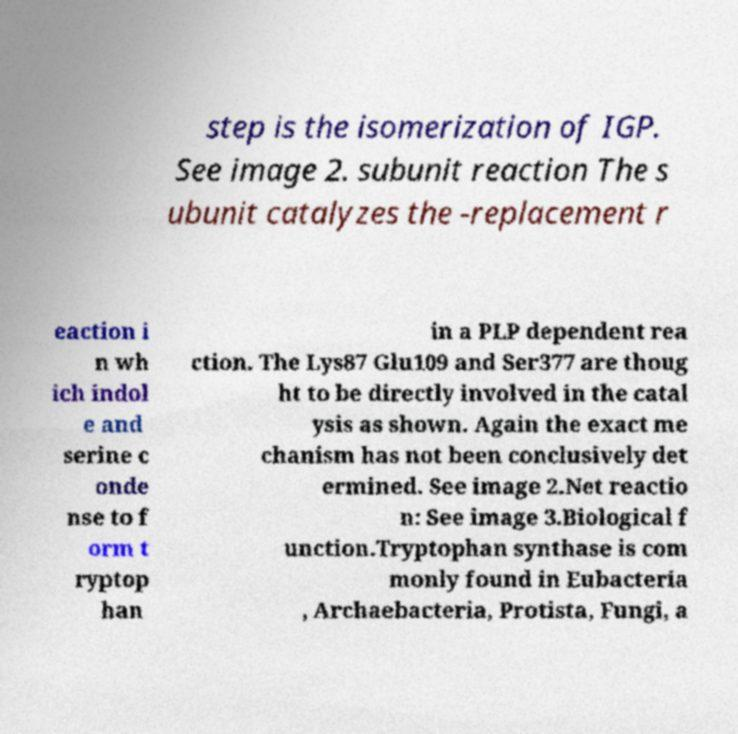Could you extract and type out the text from this image? step is the isomerization of IGP. See image 2. subunit reaction The s ubunit catalyzes the -replacement r eaction i n wh ich indol e and serine c onde nse to f orm t ryptop han in a PLP dependent rea ction. The Lys87 Glu109 and Ser377 are thoug ht to be directly involved in the catal ysis as shown. Again the exact me chanism has not been conclusively det ermined. See image 2.Net reactio n: See image 3.Biological f unction.Tryptophan synthase is com monly found in Eubacteria , Archaebacteria, Protista, Fungi, a 